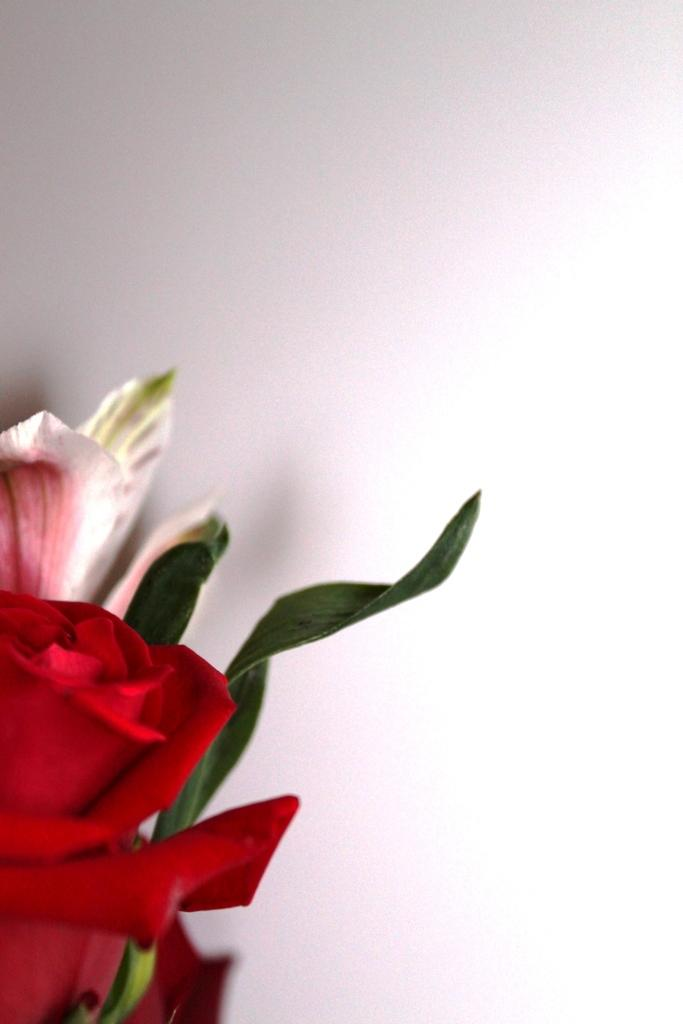What type of plant can be seen in the image? There is a flower in the image. What else is present on the plant besides the flower? There are leaves in the image. What type of school is depicted in the image? There is no school present in the image; it features a flower and leaves. How many dolls can be seen playing in the image? There are no dolls present in the image; it features a flower and leaves. 